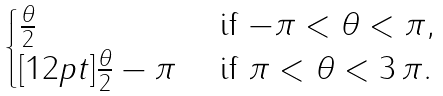<formula> <loc_0><loc_0><loc_500><loc_500>\begin{cases} \frac { \theta } { 2 } & \text { if $-\pi < \theta < \pi$} , \\ [ 1 2 p t ] \frac { \theta } { 2 } - \pi & \text { if $\pi < \theta < 3\, \pi$} . \end{cases}</formula> 